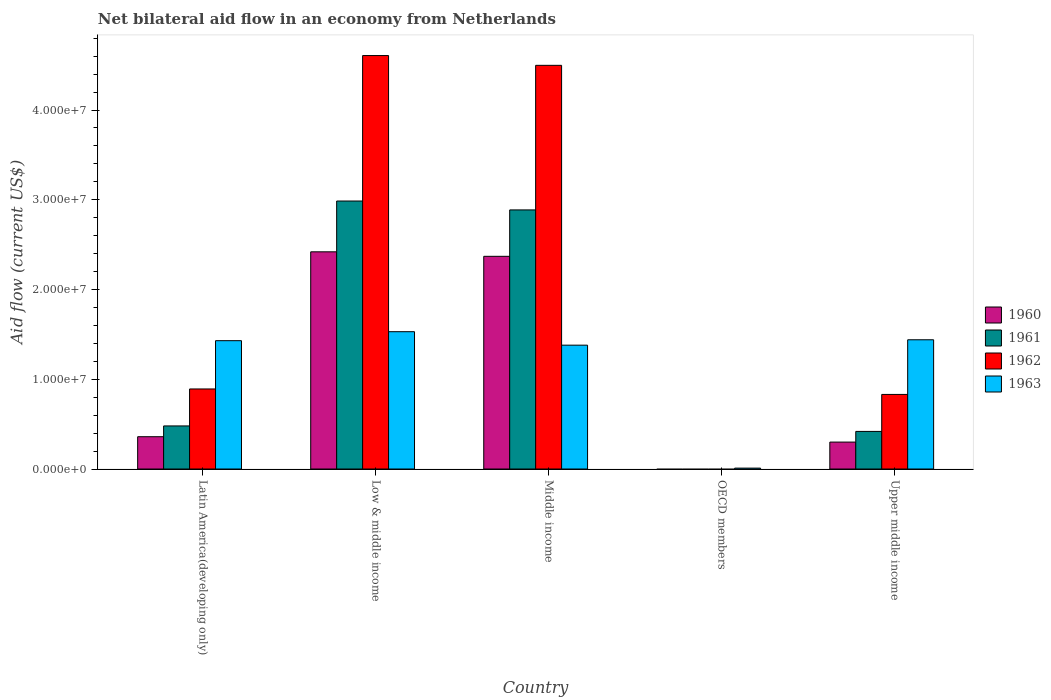How many bars are there on the 2nd tick from the left?
Make the answer very short. 4. What is the label of the 5th group of bars from the left?
Provide a succinct answer. Upper middle income. In how many cases, is the number of bars for a given country not equal to the number of legend labels?
Offer a very short reply. 1. What is the net bilateral aid flow in 1963 in Low & middle income?
Your response must be concise. 1.53e+07. Across all countries, what is the maximum net bilateral aid flow in 1960?
Keep it short and to the point. 2.42e+07. What is the total net bilateral aid flow in 1961 in the graph?
Provide a short and direct response. 6.77e+07. What is the difference between the net bilateral aid flow in 1960 in Low & middle income and that in Upper middle income?
Your response must be concise. 2.12e+07. What is the difference between the net bilateral aid flow in 1961 in Latin America(developing only) and the net bilateral aid flow in 1960 in Middle income?
Your response must be concise. -1.89e+07. What is the average net bilateral aid flow in 1963 per country?
Offer a terse response. 1.16e+07. What is the difference between the net bilateral aid flow of/in 1961 and net bilateral aid flow of/in 1960 in Upper middle income?
Your response must be concise. 1.19e+06. In how many countries, is the net bilateral aid flow in 1960 greater than 22000000 US$?
Give a very brief answer. 2. What is the ratio of the net bilateral aid flow in 1961 in Latin America(developing only) to that in Upper middle income?
Your response must be concise. 1.15. Is the net bilateral aid flow in 1963 in OECD members less than that in Upper middle income?
Keep it short and to the point. Yes. Is the difference between the net bilateral aid flow in 1961 in Latin America(developing only) and Low & middle income greater than the difference between the net bilateral aid flow in 1960 in Latin America(developing only) and Low & middle income?
Your answer should be very brief. No. What is the difference between the highest and the lowest net bilateral aid flow in 1963?
Give a very brief answer. 1.52e+07. Is the sum of the net bilateral aid flow in 1961 in Latin America(developing only) and Low & middle income greater than the maximum net bilateral aid flow in 1962 across all countries?
Keep it short and to the point. No. Is it the case that in every country, the sum of the net bilateral aid flow in 1960 and net bilateral aid flow in 1961 is greater than the sum of net bilateral aid flow in 1962 and net bilateral aid flow in 1963?
Your answer should be very brief. No. What is the difference between two consecutive major ticks on the Y-axis?
Provide a short and direct response. 1.00e+07. Are the values on the major ticks of Y-axis written in scientific E-notation?
Keep it short and to the point. Yes. Does the graph contain any zero values?
Give a very brief answer. Yes. Does the graph contain grids?
Make the answer very short. No. Where does the legend appear in the graph?
Offer a very short reply. Center right. How are the legend labels stacked?
Offer a very short reply. Vertical. What is the title of the graph?
Your response must be concise. Net bilateral aid flow in an economy from Netherlands. What is the label or title of the Y-axis?
Offer a terse response. Aid flow (current US$). What is the Aid flow (current US$) of 1960 in Latin America(developing only)?
Ensure brevity in your answer.  3.60e+06. What is the Aid flow (current US$) of 1961 in Latin America(developing only)?
Provide a short and direct response. 4.80e+06. What is the Aid flow (current US$) in 1962 in Latin America(developing only)?
Give a very brief answer. 8.92e+06. What is the Aid flow (current US$) in 1963 in Latin America(developing only)?
Provide a short and direct response. 1.43e+07. What is the Aid flow (current US$) of 1960 in Low & middle income?
Offer a terse response. 2.42e+07. What is the Aid flow (current US$) of 1961 in Low & middle income?
Give a very brief answer. 2.99e+07. What is the Aid flow (current US$) of 1962 in Low & middle income?
Make the answer very short. 4.61e+07. What is the Aid flow (current US$) in 1963 in Low & middle income?
Offer a terse response. 1.53e+07. What is the Aid flow (current US$) in 1960 in Middle income?
Your response must be concise. 2.37e+07. What is the Aid flow (current US$) in 1961 in Middle income?
Provide a succinct answer. 2.89e+07. What is the Aid flow (current US$) of 1962 in Middle income?
Offer a terse response. 4.50e+07. What is the Aid flow (current US$) of 1963 in Middle income?
Your response must be concise. 1.38e+07. What is the Aid flow (current US$) of 1960 in OECD members?
Keep it short and to the point. 0. What is the Aid flow (current US$) of 1963 in OECD members?
Offer a very short reply. 1.00e+05. What is the Aid flow (current US$) of 1961 in Upper middle income?
Offer a very short reply. 4.19e+06. What is the Aid flow (current US$) of 1962 in Upper middle income?
Your answer should be very brief. 8.31e+06. What is the Aid flow (current US$) of 1963 in Upper middle income?
Offer a very short reply. 1.44e+07. Across all countries, what is the maximum Aid flow (current US$) in 1960?
Offer a very short reply. 2.42e+07. Across all countries, what is the maximum Aid flow (current US$) of 1961?
Keep it short and to the point. 2.99e+07. Across all countries, what is the maximum Aid flow (current US$) of 1962?
Your answer should be compact. 4.61e+07. Across all countries, what is the maximum Aid flow (current US$) of 1963?
Offer a terse response. 1.53e+07. Across all countries, what is the minimum Aid flow (current US$) in 1960?
Give a very brief answer. 0. Across all countries, what is the minimum Aid flow (current US$) in 1962?
Ensure brevity in your answer.  0. Across all countries, what is the minimum Aid flow (current US$) in 1963?
Your response must be concise. 1.00e+05. What is the total Aid flow (current US$) of 1960 in the graph?
Your answer should be compact. 5.45e+07. What is the total Aid flow (current US$) in 1961 in the graph?
Your answer should be very brief. 6.77e+07. What is the total Aid flow (current US$) in 1962 in the graph?
Offer a terse response. 1.08e+08. What is the total Aid flow (current US$) of 1963 in the graph?
Give a very brief answer. 5.79e+07. What is the difference between the Aid flow (current US$) of 1960 in Latin America(developing only) and that in Low & middle income?
Give a very brief answer. -2.06e+07. What is the difference between the Aid flow (current US$) in 1961 in Latin America(developing only) and that in Low & middle income?
Your answer should be compact. -2.51e+07. What is the difference between the Aid flow (current US$) in 1962 in Latin America(developing only) and that in Low & middle income?
Provide a short and direct response. -3.72e+07. What is the difference between the Aid flow (current US$) in 1960 in Latin America(developing only) and that in Middle income?
Give a very brief answer. -2.01e+07. What is the difference between the Aid flow (current US$) of 1961 in Latin America(developing only) and that in Middle income?
Your answer should be compact. -2.41e+07. What is the difference between the Aid flow (current US$) in 1962 in Latin America(developing only) and that in Middle income?
Offer a very short reply. -3.61e+07. What is the difference between the Aid flow (current US$) in 1963 in Latin America(developing only) and that in OECD members?
Ensure brevity in your answer.  1.42e+07. What is the difference between the Aid flow (current US$) in 1960 in Latin America(developing only) and that in Upper middle income?
Your answer should be very brief. 6.00e+05. What is the difference between the Aid flow (current US$) in 1961 in Latin America(developing only) and that in Upper middle income?
Make the answer very short. 6.10e+05. What is the difference between the Aid flow (current US$) of 1960 in Low & middle income and that in Middle income?
Keep it short and to the point. 5.00e+05. What is the difference between the Aid flow (current US$) of 1961 in Low & middle income and that in Middle income?
Offer a terse response. 9.90e+05. What is the difference between the Aid flow (current US$) of 1962 in Low & middle income and that in Middle income?
Give a very brief answer. 1.09e+06. What is the difference between the Aid flow (current US$) in 1963 in Low & middle income and that in Middle income?
Offer a very short reply. 1.50e+06. What is the difference between the Aid flow (current US$) of 1963 in Low & middle income and that in OECD members?
Make the answer very short. 1.52e+07. What is the difference between the Aid flow (current US$) in 1960 in Low & middle income and that in Upper middle income?
Provide a succinct answer. 2.12e+07. What is the difference between the Aid flow (current US$) in 1961 in Low & middle income and that in Upper middle income?
Make the answer very short. 2.57e+07. What is the difference between the Aid flow (current US$) of 1962 in Low & middle income and that in Upper middle income?
Offer a terse response. 3.78e+07. What is the difference between the Aid flow (current US$) in 1963 in Middle income and that in OECD members?
Keep it short and to the point. 1.37e+07. What is the difference between the Aid flow (current US$) of 1960 in Middle income and that in Upper middle income?
Give a very brief answer. 2.07e+07. What is the difference between the Aid flow (current US$) in 1961 in Middle income and that in Upper middle income?
Provide a short and direct response. 2.47e+07. What is the difference between the Aid flow (current US$) in 1962 in Middle income and that in Upper middle income?
Provide a succinct answer. 3.67e+07. What is the difference between the Aid flow (current US$) in 1963 in Middle income and that in Upper middle income?
Give a very brief answer. -6.00e+05. What is the difference between the Aid flow (current US$) in 1963 in OECD members and that in Upper middle income?
Offer a very short reply. -1.43e+07. What is the difference between the Aid flow (current US$) of 1960 in Latin America(developing only) and the Aid flow (current US$) of 1961 in Low & middle income?
Make the answer very short. -2.63e+07. What is the difference between the Aid flow (current US$) in 1960 in Latin America(developing only) and the Aid flow (current US$) in 1962 in Low & middle income?
Provide a succinct answer. -4.25e+07. What is the difference between the Aid flow (current US$) in 1960 in Latin America(developing only) and the Aid flow (current US$) in 1963 in Low & middle income?
Make the answer very short. -1.17e+07. What is the difference between the Aid flow (current US$) of 1961 in Latin America(developing only) and the Aid flow (current US$) of 1962 in Low & middle income?
Your response must be concise. -4.13e+07. What is the difference between the Aid flow (current US$) in 1961 in Latin America(developing only) and the Aid flow (current US$) in 1963 in Low & middle income?
Offer a terse response. -1.05e+07. What is the difference between the Aid flow (current US$) in 1962 in Latin America(developing only) and the Aid flow (current US$) in 1963 in Low & middle income?
Provide a short and direct response. -6.38e+06. What is the difference between the Aid flow (current US$) in 1960 in Latin America(developing only) and the Aid flow (current US$) in 1961 in Middle income?
Make the answer very short. -2.53e+07. What is the difference between the Aid flow (current US$) in 1960 in Latin America(developing only) and the Aid flow (current US$) in 1962 in Middle income?
Provide a succinct answer. -4.14e+07. What is the difference between the Aid flow (current US$) in 1960 in Latin America(developing only) and the Aid flow (current US$) in 1963 in Middle income?
Ensure brevity in your answer.  -1.02e+07. What is the difference between the Aid flow (current US$) of 1961 in Latin America(developing only) and the Aid flow (current US$) of 1962 in Middle income?
Your answer should be very brief. -4.02e+07. What is the difference between the Aid flow (current US$) in 1961 in Latin America(developing only) and the Aid flow (current US$) in 1963 in Middle income?
Ensure brevity in your answer.  -9.00e+06. What is the difference between the Aid flow (current US$) in 1962 in Latin America(developing only) and the Aid flow (current US$) in 1963 in Middle income?
Give a very brief answer. -4.88e+06. What is the difference between the Aid flow (current US$) in 1960 in Latin America(developing only) and the Aid flow (current US$) in 1963 in OECD members?
Your response must be concise. 3.50e+06. What is the difference between the Aid flow (current US$) of 1961 in Latin America(developing only) and the Aid flow (current US$) of 1963 in OECD members?
Keep it short and to the point. 4.70e+06. What is the difference between the Aid flow (current US$) of 1962 in Latin America(developing only) and the Aid flow (current US$) of 1963 in OECD members?
Offer a terse response. 8.82e+06. What is the difference between the Aid flow (current US$) in 1960 in Latin America(developing only) and the Aid flow (current US$) in 1961 in Upper middle income?
Your response must be concise. -5.90e+05. What is the difference between the Aid flow (current US$) of 1960 in Latin America(developing only) and the Aid flow (current US$) of 1962 in Upper middle income?
Your answer should be compact. -4.71e+06. What is the difference between the Aid flow (current US$) in 1960 in Latin America(developing only) and the Aid flow (current US$) in 1963 in Upper middle income?
Ensure brevity in your answer.  -1.08e+07. What is the difference between the Aid flow (current US$) in 1961 in Latin America(developing only) and the Aid flow (current US$) in 1962 in Upper middle income?
Offer a very short reply. -3.51e+06. What is the difference between the Aid flow (current US$) of 1961 in Latin America(developing only) and the Aid flow (current US$) of 1963 in Upper middle income?
Give a very brief answer. -9.60e+06. What is the difference between the Aid flow (current US$) of 1962 in Latin America(developing only) and the Aid flow (current US$) of 1963 in Upper middle income?
Ensure brevity in your answer.  -5.48e+06. What is the difference between the Aid flow (current US$) in 1960 in Low & middle income and the Aid flow (current US$) in 1961 in Middle income?
Your answer should be very brief. -4.67e+06. What is the difference between the Aid flow (current US$) in 1960 in Low & middle income and the Aid flow (current US$) in 1962 in Middle income?
Make the answer very short. -2.08e+07. What is the difference between the Aid flow (current US$) of 1960 in Low & middle income and the Aid flow (current US$) of 1963 in Middle income?
Ensure brevity in your answer.  1.04e+07. What is the difference between the Aid flow (current US$) of 1961 in Low & middle income and the Aid flow (current US$) of 1962 in Middle income?
Your answer should be compact. -1.51e+07. What is the difference between the Aid flow (current US$) in 1961 in Low & middle income and the Aid flow (current US$) in 1963 in Middle income?
Your answer should be compact. 1.61e+07. What is the difference between the Aid flow (current US$) of 1962 in Low & middle income and the Aid flow (current US$) of 1963 in Middle income?
Keep it short and to the point. 3.23e+07. What is the difference between the Aid flow (current US$) of 1960 in Low & middle income and the Aid flow (current US$) of 1963 in OECD members?
Offer a terse response. 2.41e+07. What is the difference between the Aid flow (current US$) of 1961 in Low & middle income and the Aid flow (current US$) of 1963 in OECD members?
Your answer should be very brief. 2.98e+07. What is the difference between the Aid flow (current US$) in 1962 in Low & middle income and the Aid flow (current US$) in 1963 in OECD members?
Offer a very short reply. 4.60e+07. What is the difference between the Aid flow (current US$) in 1960 in Low & middle income and the Aid flow (current US$) in 1961 in Upper middle income?
Ensure brevity in your answer.  2.00e+07. What is the difference between the Aid flow (current US$) of 1960 in Low & middle income and the Aid flow (current US$) of 1962 in Upper middle income?
Keep it short and to the point. 1.59e+07. What is the difference between the Aid flow (current US$) in 1960 in Low & middle income and the Aid flow (current US$) in 1963 in Upper middle income?
Keep it short and to the point. 9.80e+06. What is the difference between the Aid flow (current US$) in 1961 in Low & middle income and the Aid flow (current US$) in 1962 in Upper middle income?
Your response must be concise. 2.16e+07. What is the difference between the Aid flow (current US$) of 1961 in Low & middle income and the Aid flow (current US$) of 1963 in Upper middle income?
Offer a terse response. 1.55e+07. What is the difference between the Aid flow (current US$) of 1962 in Low & middle income and the Aid flow (current US$) of 1963 in Upper middle income?
Provide a succinct answer. 3.17e+07. What is the difference between the Aid flow (current US$) in 1960 in Middle income and the Aid flow (current US$) in 1963 in OECD members?
Your answer should be very brief. 2.36e+07. What is the difference between the Aid flow (current US$) in 1961 in Middle income and the Aid flow (current US$) in 1963 in OECD members?
Provide a succinct answer. 2.88e+07. What is the difference between the Aid flow (current US$) in 1962 in Middle income and the Aid flow (current US$) in 1963 in OECD members?
Offer a terse response. 4.49e+07. What is the difference between the Aid flow (current US$) in 1960 in Middle income and the Aid flow (current US$) in 1961 in Upper middle income?
Your answer should be very brief. 1.95e+07. What is the difference between the Aid flow (current US$) in 1960 in Middle income and the Aid flow (current US$) in 1962 in Upper middle income?
Keep it short and to the point. 1.54e+07. What is the difference between the Aid flow (current US$) in 1960 in Middle income and the Aid flow (current US$) in 1963 in Upper middle income?
Keep it short and to the point. 9.30e+06. What is the difference between the Aid flow (current US$) of 1961 in Middle income and the Aid flow (current US$) of 1962 in Upper middle income?
Offer a terse response. 2.06e+07. What is the difference between the Aid flow (current US$) in 1961 in Middle income and the Aid flow (current US$) in 1963 in Upper middle income?
Your answer should be very brief. 1.45e+07. What is the difference between the Aid flow (current US$) of 1962 in Middle income and the Aid flow (current US$) of 1963 in Upper middle income?
Ensure brevity in your answer.  3.06e+07. What is the average Aid flow (current US$) of 1960 per country?
Give a very brief answer. 1.09e+07. What is the average Aid flow (current US$) of 1961 per country?
Offer a terse response. 1.35e+07. What is the average Aid flow (current US$) in 1962 per country?
Give a very brief answer. 2.17e+07. What is the average Aid flow (current US$) of 1963 per country?
Ensure brevity in your answer.  1.16e+07. What is the difference between the Aid flow (current US$) of 1960 and Aid flow (current US$) of 1961 in Latin America(developing only)?
Your answer should be very brief. -1.20e+06. What is the difference between the Aid flow (current US$) of 1960 and Aid flow (current US$) of 1962 in Latin America(developing only)?
Make the answer very short. -5.32e+06. What is the difference between the Aid flow (current US$) in 1960 and Aid flow (current US$) in 1963 in Latin America(developing only)?
Provide a short and direct response. -1.07e+07. What is the difference between the Aid flow (current US$) of 1961 and Aid flow (current US$) of 1962 in Latin America(developing only)?
Make the answer very short. -4.12e+06. What is the difference between the Aid flow (current US$) in 1961 and Aid flow (current US$) in 1963 in Latin America(developing only)?
Provide a succinct answer. -9.50e+06. What is the difference between the Aid flow (current US$) of 1962 and Aid flow (current US$) of 1963 in Latin America(developing only)?
Ensure brevity in your answer.  -5.38e+06. What is the difference between the Aid flow (current US$) of 1960 and Aid flow (current US$) of 1961 in Low & middle income?
Make the answer very short. -5.66e+06. What is the difference between the Aid flow (current US$) of 1960 and Aid flow (current US$) of 1962 in Low & middle income?
Provide a succinct answer. -2.19e+07. What is the difference between the Aid flow (current US$) of 1960 and Aid flow (current US$) of 1963 in Low & middle income?
Offer a very short reply. 8.90e+06. What is the difference between the Aid flow (current US$) in 1961 and Aid flow (current US$) in 1962 in Low & middle income?
Your response must be concise. -1.62e+07. What is the difference between the Aid flow (current US$) of 1961 and Aid flow (current US$) of 1963 in Low & middle income?
Your response must be concise. 1.46e+07. What is the difference between the Aid flow (current US$) of 1962 and Aid flow (current US$) of 1963 in Low & middle income?
Offer a very short reply. 3.08e+07. What is the difference between the Aid flow (current US$) in 1960 and Aid flow (current US$) in 1961 in Middle income?
Provide a short and direct response. -5.17e+06. What is the difference between the Aid flow (current US$) of 1960 and Aid flow (current US$) of 1962 in Middle income?
Provide a succinct answer. -2.13e+07. What is the difference between the Aid flow (current US$) of 1960 and Aid flow (current US$) of 1963 in Middle income?
Your answer should be compact. 9.90e+06. What is the difference between the Aid flow (current US$) in 1961 and Aid flow (current US$) in 1962 in Middle income?
Offer a terse response. -1.61e+07. What is the difference between the Aid flow (current US$) of 1961 and Aid flow (current US$) of 1963 in Middle income?
Keep it short and to the point. 1.51e+07. What is the difference between the Aid flow (current US$) in 1962 and Aid flow (current US$) in 1963 in Middle income?
Offer a very short reply. 3.12e+07. What is the difference between the Aid flow (current US$) in 1960 and Aid flow (current US$) in 1961 in Upper middle income?
Keep it short and to the point. -1.19e+06. What is the difference between the Aid flow (current US$) in 1960 and Aid flow (current US$) in 1962 in Upper middle income?
Offer a very short reply. -5.31e+06. What is the difference between the Aid flow (current US$) of 1960 and Aid flow (current US$) of 1963 in Upper middle income?
Your answer should be very brief. -1.14e+07. What is the difference between the Aid flow (current US$) in 1961 and Aid flow (current US$) in 1962 in Upper middle income?
Ensure brevity in your answer.  -4.12e+06. What is the difference between the Aid flow (current US$) of 1961 and Aid flow (current US$) of 1963 in Upper middle income?
Provide a succinct answer. -1.02e+07. What is the difference between the Aid flow (current US$) in 1962 and Aid flow (current US$) in 1963 in Upper middle income?
Provide a short and direct response. -6.09e+06. What is the ratio of the Aid flow (current US$) in 1960 in Latin America(developing only) to that in Low & middle income?
Offer a terse response. 0.15. What is the ratio of the Aid flow (current US$) of 1961 in Latin America(developing only) to that in Low & middle income?
Make the answer very short. 0.16. What is the ratio of the Aid flow (current US$) of 1962 in Latin America(developing only) to that in Low & middle income?
Keep it short and to the point. 0.19. What is the ratio of the Aid flow (current US$) in 1963 in Latin America(developing only) to that in Low & middle income?
Offer a terse response. 0.93. What is the ratio of the Aid flow (current US$) in 1960 in Latin America(developing only) to that in Middle income?
Offer a very short reply. 0.15. What is the ratio of the Aid flow (current US$) of 1961 in Latin America(developing only) to that in Middle income?
Provide a short and direct response. 0.17. What is the ratio of the Aid flow (current US$) in 1962 in Latin America(developing only) to that in Middle income?
Provide a short and direct response. 0.2. What is the ratio of the Aid flow (current US$) in 1963 in Latin America(developing only) to that in Middle income?
Keep it short and to the point. 1.04. What is the ratio of the Aid flow (current US$) in 1963 in Latin America(developing only) to that in OECD members?
Offer a very short reply. 143. What is the ratio of the Aid flow (current US$) of 1961 in Latin America(developing only) to that in Upper middle income?
Ensure brevity in your answer.  1.15. What is the ratio of the Aid flow (current US$) of 1962 in Latin America(developing only) to that in Upper middle income?
Your response must be concise. 1.07. What is the ratio of the Aid flow (current US$) in 1963 in Latin America(developing only) to that in Upper middle income?
Give a very brief answer. 0.99. What is the ratio of the Aid flow (current US$) in 1960 in Low & middle income to that in Middle income?
Provide a succinct answer. 1.02. What is the ratio of the Aid flow (current US$) of 1961 in Low & middle income to that in Middle income?
Offer a terse response. 1.03. What is the ratio of the Aid flow (current US$) in 1962 in Low & middle income to that in Middle income?
Provide a succinct answer. 1.02. What is the ratio of the Aid flow (current US$) in 1963 in Low & middle income to that in Middle income?
Provide a short and direct response. 1.11. What is the ratio of the Aid flow (current US$) in 1963 in Low & middle income to that in OECD members?
Offer a very short reply. 153. What is the ratio of the Aid flow (current US$) in 1960 in Low & middle income to that in Upper middle income?
Your answer should be very brief. 8.07. What is the ratio of the Aid flow (current US$) of 1961 in Low & middle income to that in Upper middle income?
Give a very brief answer. 7.13. What is the ratio of the Aid flow (current US$) in 1962 in Low & middle income to that in Upper middle income?
Your answer should be compact. 5.54. What is the ratio of the Aid flow (current US$) in 1963 in Middle income to that in OECD members?
Ensure brevity in your answer.  138. What is the ratio of the Aid flow (current US$) of 1960 in Middle income to that in Upper middle income?
Make the answer very short. 7.9. What is the ratio of the Aid flow (current US$) of 1961 in Middle income to that in Upper middle income?
Your answer should be very brief. 6.89. What is the ratio of the Aid flow (current US$) of 1962 in Middle income to that in Upper middle income?
Your answer should be compact. 5.41. What is the ratio of the Aid flow (current US$) of 1963 in OECD members to that in Upper middle income?
Make the answer very short. 0.01. What is the difference between the highest and the second highest Aid flow (current US$) in 1961?
Make the answer very short. 9.90e+05. What is the difference between the highest and the second highest Aid flow (current US$) in 1962?
Offer a very short reply. 1.09e+06. What is the difference between the highest and the lowest Aid flow (current US$) in 1960?
Ensure brevity in your answer.  2.42e+07. What is the difference between the highest and the lowest Aid flow (current US$) of 1961?
Your answer should be compact. 2.99e+07. What is the difference between the highest and the lowest Aid flow (current US$) in 1962?
Keep it short and to the point. 4.61e+07. What is the difference between the highest and the lowest Aid flow (current US$) in 1963?
Offer a very short reply. 1.52e+07. 